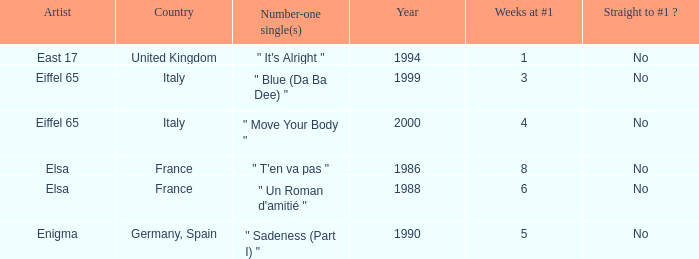In which years is the total number of weeks at #1 exactly 8? 1.0. 